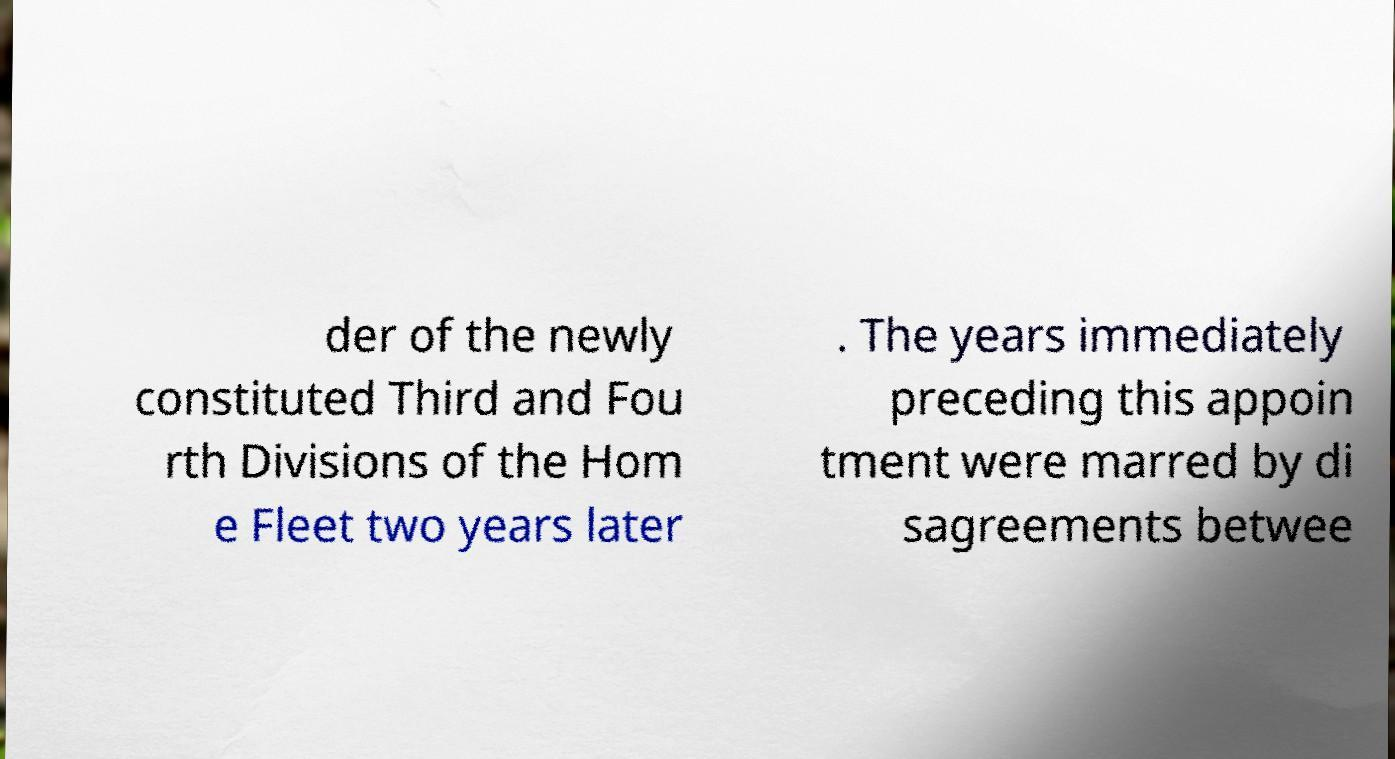Could you extract and type out the text from this image? der of the newly constituted Third and Fou rth Divisions of the Hom e Fleet two years later . The years immediately preceding this appoin tment were marred by di sagreements betwee 